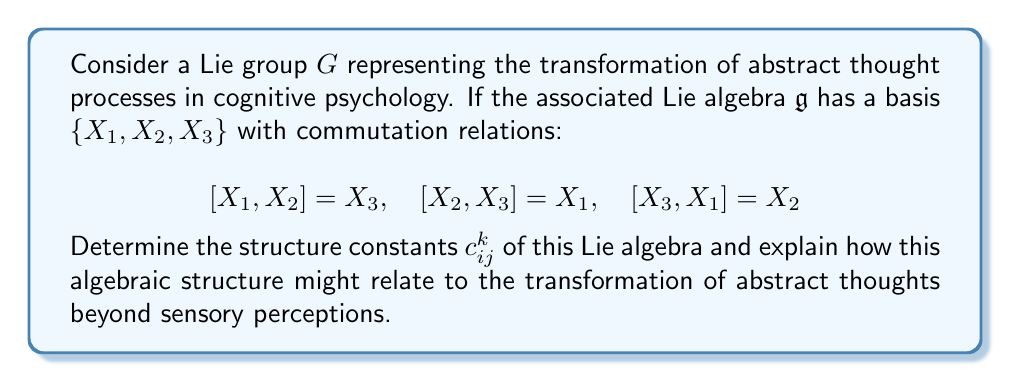What is the answer to this math problem? To solve this problem, we need to understand the concept of structure constants in Lie algebras and their potential interpretation in the context of cognitive psychology.

1) In a Lie algebra, the structure constants $c_{ij}^k$ are defined by the equation:

   $$[X_i, X_j] = \sum_k c_{ij}^k X_k$$

2) From the given commutation relations, we can identify the non-zero structure constants:

   $[X_1, X_2] = X_3 \implies c_{12}^3 = 1$
   $[X_2, X_3] = X_1 \implies c_{23}^1 = 1$
   $[X_3, X_1] = X_2 \implies c_{31}^2 = 1$

3) Note that the structure constants are antisymmetric in the lower indices:

   $c_{ij}^k = -c_{ji}^k$

   So we also have:
   $c_{21}^3 = -1$, $c_{32}^1 = -1$, $c_{13}^2 = -1$

4) All other structure constants are zero.

5) This Lie algebra is actually isomorphic to $\mathfrak{so}(3)$, the Lie algebra of the special orthogonal group SO(3), which describes rotations in three-dimensional space.

6) In the context of abstract thought processes, we can interpret this algebraic structure as follows:

   - The three basis elements $X_1$, $X_2$, and $X_3$ could represent three fundamental aspects of abstract thought, such as conceptualization, analysis, and synthesis.
   
   - The commutation relations show how these aspects interact and transform into each other, suggesting that abstract thoughts are not static but dynamically interrelated.
   
   - The fact that this algebra is isomorphic to $\mathfrak{so}(3)$ suggests that abstract thought processes might have a geometrical interpretation in a three-dimensional "thought space," where transformations of ideas correspond to rotations in this space.
   
   - This algebraic structure provides a framework for understanding how abstract thoughts can evolve and transform beyond the constraints of sensory perceptions, aligning with the perspective that human understanding can transcend sensory inputs.

7) The Lie group $G$ associated with this algebra would represent the global structure of these thought transformations, while the Lie algebra $\mathfrak{g}$ captures the infinitesimal transformations or the local structure.
Answer: The non-zero structure constants are:
$c_{12}^3 = c_{23}^1 = c_{31}^2 = 1$
$c_{21}^3 = c_{32}^1 = c_{13}^2 = -1$
All other $c_{ij}^k = 0$

This Lie algebra structure, isomorphic to $\mathfrak{so}(3)$, suggests that abstract thought processes can be modeled as rotations in a three-dimensional "thought space," providing a mathematical framework for understanding how abstract ideas can transform and transcend sensory perceptions. 